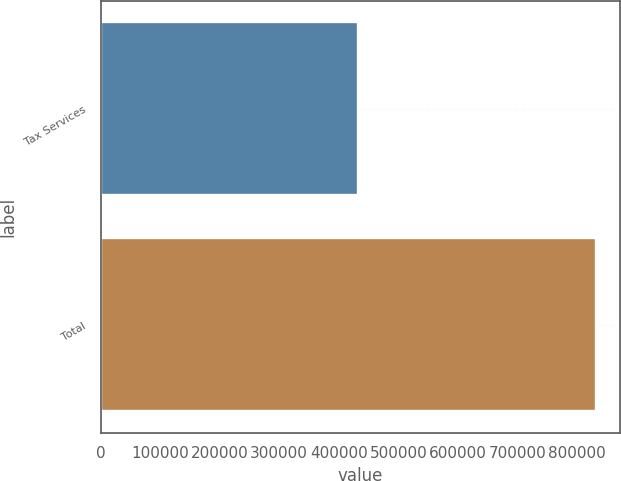Convert chart. <chart><loc_0><loc_0><loc_500><loc_500><bar_chart><fcel>Tax Services<fcel>Total<nl><fcel>431981<fcel>831314<nl></chart> 